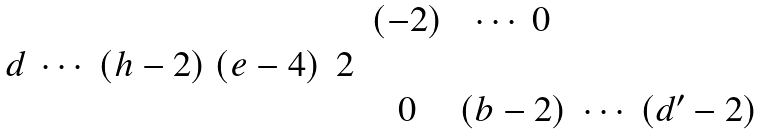Convert formula to latex. <formula><loc_0><loc_0><loc_500><loc_500>\begin{matrix} & & ( - 2 ) & \cdots \ 0 & \\ d \ \cdots \ ( h - 2 ) \ ( e - 4 ) & 2 & & & \\ & & 0 & ( b - 2 ) & \cdots \ ( d ^ { \prime } - 2 ) \end{matrix}</formula> 